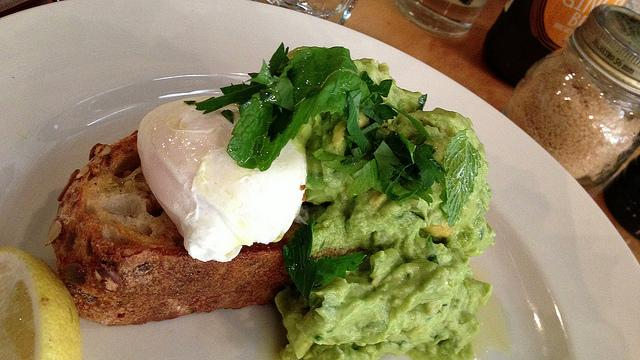What is the light green mixture? Please explain your reasoning. guacamole. Guacamole is on the bread. 